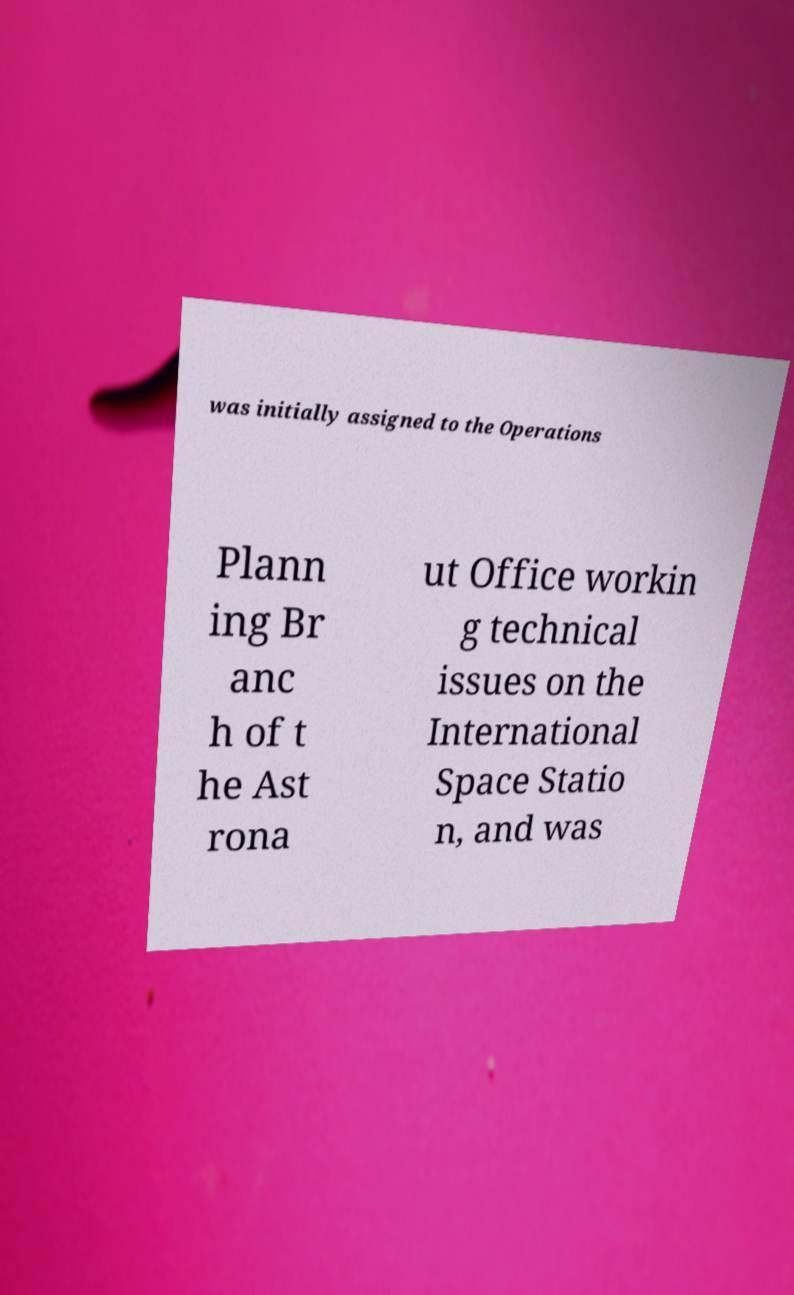Can you read and provide the text displayed in the image?This photo seems to have some interesting text. Can you extract and type it out for me? was initially assigned to the Operations Plann ing Br anc h of t he Ast rona ut Office workin g technical issues on the International Space Statio n, and was 